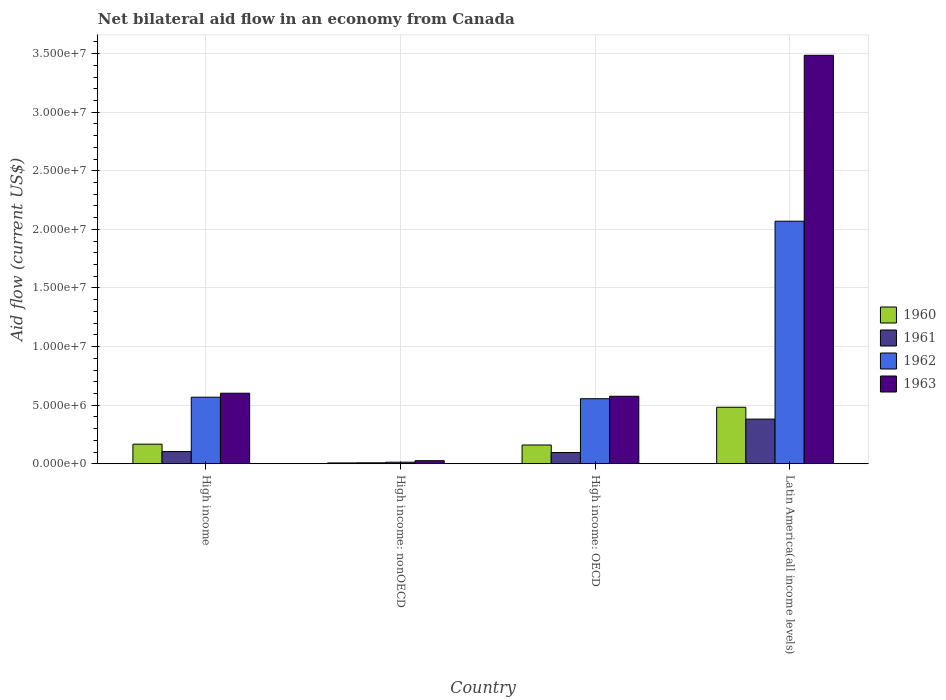Are the number of bars on each tick of the X-axis equal?
Your response must be concise. Yes. How many bars are there on the 4th tick from the left?
Make the answer very short. 4. How many bars are there on the 1st tick from the right?
Keep it short and to the point. 4. In how many cases, is the number of bars for a given country not equal to the number of legend labels?
Provide a short and direct response. 0. Across all countries, what is the maximum net bilateral aid flow in 1963?
Your response must be concise. 3.49e+07. Across all countries, what is the minimum net bilateral aid flow in 1961?
Make the answer very short. 8.00e+04. In which country was the net bilateral aid flow in 1961 maximum?
Provide a short and direct response. Latin America(all income levels). In which country was the net bilateral aid flow in 1961 minimum?
Ensure brevity in your answer.  High income: nonOECD. What is the total net bilateral aid flow in 1960 in the graph?
Keep it short and to the point. 8.16e+06. What is the difference between the net bilateral aid flow in 1963 in High income and that in High income: nonOECD?
Keep it short and to the point. 5.76e+06. What is the difference between the net bilateral aid flow in 1962 in Latin America(all income levels) and the net bilateral aid flow in 1960 in High income: OECD?
Offer a terse response. 1.91e+07. What is the average net bilateral aid flow in 1962 per country?
Your response must be concise. 8.02e+06. What is the difference between the net bilateral aid flow of/in 1960 and net bilateral aid flow of/in 1961 in High income: nonOECD?
Ensure brevity in your answer.  -10000. What is the ratio of the net bilateral aid flow in 1962 in High income to that in High income: nonOECD?
Ensure brevity in your answer.  43.69. Is the net bilateral aid flow in 1962 in High income less than that in High income: nonOECD?
Give a very brief answer. No. Is the difference between the net bilateral aid flow in 1960 in High income and High income: OECD greater than the difference between the net bilateral aid flow in 1961 in High income and High income: OECD?
Offer a very short reply. No. What is the difference between the highest and the second highest net bilateral aid flow in 1961?
Give a very brief answer. 2.85e+06. What is the difference between the highest and the lowest net bilateral aid flow in 1962?
Provide a short and direct response. 2.06e+07. Is the sum of the net bilateral aid flow in 1961 in High income: OECD and Latin America(all income levels) greater than the maximum net bilateral aid flow in 1963 across all countries?
Ensure brevity in your answer.  No. What does the 4th bar from the left in High income: nonOECD represents?
Keep it short and to the point. 1963. What does the 1st bar from the right in High income: OECD represents?
Make the answer very short. 1963. How many bars are there?
Your answer should be compact. 16. Are all the bars in the graph horizontal?
Offer a very short reply. No. How many countries are there in the graph?
Make the answer very short. 4. What is the difference between two consecutive major ticks on the Y-axis?
Give a very brief answer. 5.00e+06. Are the values on the major ticks of Y-axis written in scientific E-notation?
Offer a very short reply. Yes. Does the graph contain grids?
Provide a succinct answer. Yes. Where does the legend appear in the graph?
Give a very brief answer. Center right. How many legend labels are there?
Provide a succinct answer. 4. What is the title of the graph?
Ensure brevity in your answer.  Net bilateral aid flow in an economy from Canada. Does "1990" appear as one of the legend labels in the graph?
Ensure brevity in your answer.  No. What is the Aid flow (current US$) in 1960 in High income?
Make the answer very short. 1.67e+06. What is the Aid flow (current US$) of 1961 in High income?
Ensure brevity in your answer.  1.04e+06. What is the Aid flow (current US$) of 1962 in High income?
Your answer should be compact. 5.68e+06. What is the Aid flow (current US$) in 1963 in High income?
Ensure brevity in your answer.  6.02e+06. What is the Aid flow (current US$) of 1963 in High income: nonOECD?
Offer a very short reply. 2.60e+05. What is the Aid flow (current US$) of 1960 in High income: OECD?
Provide a succinct answer. 1.60e+06. What is the Aid flow (current US$) of 1961 in High income: OECD?
Make the answer very short. 9.60e+05. What is the Aid flow (current US$) in 1962 in High income: OECD?
Your response must be concise. 5.55e+06. What is the Aid flow (current US$) of 1963 in High income: OECD?
Your answer should be compact. 5.76e+06. What is the Aid flow (current US$) of 1960 in Latin America(all income levels)?
Ensure brevity in your answer.  4.82e+06. What is the Aid flow (current US$) of 1961 in Latin America(all income levels)?
Provide a short and direct response. 3.81e+06. What is the Aid flow (current US$) in 1962 in Latin America(all income levels)?
Your answer should be compact. 2.07e+07. What is the Aid flow (current US$) in 1963 in Latin America(all income levels)?
Ensure brevity in your answer.  3.49e+07. Across all countries, what is the maximum Aid flow (current US$) of 1960?
Your answer should be very brief. 4.82e+06. Across all countries, what is the maximum Aid flow (current US$) of 1961?
Make the answer very short. 3.81e+06. Across all countries, what is the maximum Aid flow (current US$) of 1962?
Keep it short and to the point. 2.07e+07. Across all countries, what is the maximum Aid flow (current US$) of 1963?
Your response must be concise. 3.49e+07. Across all countries, what is the minimum Aid flow (current US$) in 1960?
Provide a short and direct response. 7.00e+04. Across all countries, what is the minimum Aid flow (current US$) in 1961?
Your response must be concise. 8.00e+04. Across all countries, what is the minimum Aid flow (current US$) in 1963?
Provide a succinct answer. 2.60e+05. What is the total Aid flow (current US$) of 1960 in the graph?
Provide a short and direct response. 8.16e+06. What is the total Aid flow (current US$) of 1961 in the graph?
Your answer should be very brief. 5.89e+06. What is the total Aid flow (current US$) of 1962 in the graph?
Your answer should be very brief. 3.21e+07. What is the total Aid flow (current US$) in 1963 in the graph?
Your answer should be compact. 4.69e+07. What is the difference between the Aid flow (current US$) of 1960 in High income and that in High income: nonOECD?
Provide a short and direct response. 1.60e+06. What is the difference between the Aid flow (current US$) of 1961 in High income and that in High income: nonOECD?
Offer a very short reply. 9.60e+05. What is the difference between the Aid flow (current US$) in 1962 in High income and that in High income: nonOECD?
Provide a short and direct response. 5.55e+06. What is the difference between the Aid flow (current US$) of 1963 in High income and that in High income: nonOECD?
Your answer should be compact. 5.76e+06. What is the difference between the Aid flow (current US$) of 1963 in High income and that in High income: OECD?
Ensure brevity in your answer.  2.60e+05. What is the difference between the Aid flow (current US$) of 1960 in High income and that in Latin America(all income levels)?
Your response must be concise. -3.15e+06. What is the difference between the Aid flow (current US$) in 1961 in High income and that in Latin America(all income levels)?
Keep it short and to the point. -2.77e+06. What is the difference between the Aid flow (current US$) of 1962 in High income and that in Latin America(all income levels)?
Ensure brevity in your answer.  -1.50e+07. What is the difference between the Aid flow (current US$) of 1963 in High income and that in Latin America(all income levels)?
Your response must be concise. -2.88e+07. What is the difference between the Aid flow (current US$) in 1960 in High income: nonOECD and that in High income: OECD?
Provide a succinct answer. -1.53e+06. What is the difference between the Aid flow (current US$) in 1961 in High income: nonOECD and that in High income: OECD?
Offer a terse response. -8.80e+05. What is the difference between the Aid flow (current US$) of 1962 in High income: nonOECD and that in High income: OECD?
Your response must be concise. -5.42e+06. What is the difference between the Aid flow (current US$) of 1963 in High income: nonOECD and that in High income: OECD?
Offer a terse response. -5.50e+06. What is the difference between the Aid flow (current US$) in 1960 in High income: nonOECD and that in Latin America(all income levels)?
Your response must be concise. -4.75e+06. What is the difference between the Aid flow (current US$) of 1961 in High income: nonOECD and that in Latin America(all income levels)?
Your response must be concise. -3.73e+06. What is the difference between the Aid flow (current US$) in 1962 in High income: nonOECD and that in Latin America(all income levels)?
Ensure brevity in your answer.  -2.06e+07. What is the difference between the Aid flow (current US$) of 1963 in High income: nonOECD and that in Latin America(all income levels)?
Ensure brevity in your answer.  -3.46e+07. What is the difference between the Aid flow (current US$) of 1960 in High income: OECD and that in Latin America(all income levels)?
Your response must be concise. -3.22e+06. What is the difference between the Aid flow (current US$) in 1961 in High income: OECD and that in Latin America(all income levels)?
Provide a succinct answer. -2.85e+06. What is the difference between the Aid flow (current US$) in 1962 in High income: OECD and that in Latin America(all income levels)?
Give a very brief answer. -1.52e+07. What is the difference between the Aid flow (current US$) in 1963 in High income: OECD and that in Latin America(all income levels)?
Keep it short and to the point. -2.91e+07. What is the difference between the Aid flow (current US$) in 1960 in High income and the Aid flow (current US$) in 1961 in High income: nonOECD?
Keep it short and to the point. 1.59e+06. What is the difference between the Aid flow (current US$) in 1960 in High income and the Aid flow (current US$) in 1962 in High income: nonOECD?
Ensure brevity in your answer.  1.54e+06. What is the difference between the Aid flow (current US$) of 1960 in High income and the Aid flow (current US$) of 1963 in High income: nonOECD?
Offer a very short reply. 1.41e+06. What is the difference between the Aid flow (current US$) in 1961 in High income and the Aid flow (current US$) in 1962 in High income: nonOECD?
Keep it short and to the point. 9.10e+05. What is the difference between the Aid flow (current US$) of 1961 in High income and the Aid flow (current US$) of 1963 in High income: nonOECD?
Your answer should be compact. 7.80e+05. What is the difference between the Aid flow (current US$) in 1962 in High income and the Aid flow (current US$) in 1963 in High income: nonOECD?
Give a very brief answer. 5.42e+06. What is the difference between the Aid flow (current US$) of 1960 in High income and the Aid flow (current US$) of 1961 in High income: OECD?
Your response must be concise. 7.10e+05. What is the difference between the Aid flow (current US$) in 1960 in High income and the Aid flow (current US$) in 1962 in High income: OECD?
Offer a terse response. -3.88e+06. What is the difference between the Aid flow (current US$) in 1960 in High income and the Aid flow (current US$) in 1963 in High income: OECD?
Your answer should be compact. -4.09e+06. What is the difference between the Aid flow (current US$) in 1961 in High income and the Aid flow (current US$) in 1962 in High income: OECD?
Your answer should be compact. -4.51e+06. What is the difference between the Aid flow (current US$) in 1961 in High income and the Aid flow (current US$) in 1963 in High income: OECD?
Make the answer very short. -4.72e+06. What is the difference between the Aid flow (current US$) in 1960 in High income and the Aid flow (current US$) in 1961 in Latin America(all income levels)?
Your response must be concise. -2.14e+06. What is the difference between the Aid flow (current US$) of 1960 in High income and the Aid flow (current US$) of 1962 in Latin America(all income levels)?
Your response must be concise. -1.90e+07. What is the difference between the Aid flow (current US$) in 1960 in High income and the Aid flow (current US$) in 1963 in Latin America(all income levels)?
Your answer should be very brief. -3.32e+07. What is the difference between the Aid flow (current US$) in 1961 in High income and the Aid flow (current US$) in 1962 in Latin America(all income levels)?
Provide a short and direct response. -1.97e+07. What is the difference between the Aid flow (current US$) in 1961 in High income and the Aid flow (current US$) in 1963 in Latin America(all income levels)?
Provide a short and direct response. -3.38e+07. What is the difference between the Aid flow (current US$) in 1962 in High income and the Aid flow (current US$) in 1963 in Latin America(all income levels)?
Offer a terse response. -2.92e+07. What is the difference between the Aid flow (current US$) in 1960 in High income: nonOECD and the Aid flow (current US$) in 1961 in High income: OECD?
Offer a very short reply. -8.90e+05. What is the difference between the Aid flow (current US$) of 1960 in High income: nonOECD and the Aid flow (current US$) of 1962 in High income: OECD?
Keep it short and to the point. -5.48e+06. What is the difference between the Aid flow (current US$) of 1960 in High income: nonOECD and the Aid flow (current US$) of 1963 in High income: OECD?
Keep it short and to the point. -5.69e+06. What is the difference between the Aid flow (current US$) in 1961 in High income: nonOECD and the Aid flow (current US$) in 1962 in High income: OECD?
Offer a very short reply. -5.47e+06. What is the difference between the Aid flow (current US$) in 1961 in High income: nonOECD and the Aid flow (current US$) in 1963 in High income: OECD?
Your answer should be very brief. -5.68e+06. What is the difference between the Aid flow (current US$) of 1962 in High income: nonOECD and the Aid flow (current US$) of 1963 in High income: OECD?
Make the answer very short. -5.63e+06. What is the difference between the Aid flow (current US$) of 1960 in High income: nonOECD and the Aid flow (current US$) of 1961 in Latin America(all income levels)?
Provide a succinct answer. -3.74e+06. What is the difference between the Aid flow (current US$) in 1960 in High income: nonOECD and the Aid flow (current US$) in 1962 in Latin America(all income levels)?
Offer a very short reply. -2.06e+07. What is the difference between the Aid flow (current US$) in 1960 in High income: nonOECD and the Aid flow (current US$) in 1963 in Latin America(all income levels)?
Offer a terse response. -3.48e+07. What is the difference between the Aid flow (current US$) in 1961 in High income: nonOECD and the Aid flow (current US$) in 1962 in Latin America(all income levels)?
Keep it short and to the point. -2.06e+07. What is the difference between the Aid flow (current US$) in 1961 in High income: nonOECD and the Aid flow (current US$) in 1963 in Latin America(all income levels)?
Provide a succinct answer. -3.48e+07. What is the difference between the Aid flow (current US$) of 1962 in High income: nonOECD and the Aid flow (current US$) of 1963 in Latin America(all income levels)?
Offer a very short reply. -3.47e+07. What is the difference between the Aid flow (current US$) of 1960 in High income: OECD and the Aid flow (current US$) of 1961 in Latin America(all income levels)?
Offer a very short reply. -2.21e+06. What is the difference between the Aid flow (current US$) in 1960 in High income: OECD and the Aid flow (current US$) in 1962 in Latin America(all income levels)?
Keep it short and to the point. -1.91e+07. What is the difference between the Aid flow (current US$) in 1960 in High income: OECD and the Aid flow (current US$) in 1963 in Latin America(all income levels)?
Offer a terse response. -3.33e+07. What is the difference between the Aid flow (current US$) in 1961 in High income: OECD and the Aid flow (current US$) in 1962 in Latin America(all income levels)?
Provide a short and direct response. -1.97e+07. What is the difference between the Aid flow (current US$) in 1961 in High income: OECD and the Aid flow (current US$) in 1963 in Latin America(all income levels)?
Ensure brevity in your answer.  -3.39e+07. What is the difference between the Aid flow (current US$) in 1962 in High income: OECD and the Aid flow (current US$) in 1963 in Latin America(all income levels)?
Offer a very short reply. -2.93e+07. What is the average Aid flow (current US$) in 1960 per country?
Offer a terse response. 2.04e+06. What is the average Aid flow (current US$) of 1961 per country?
Provide a succinct answer. 1.47e+06. What is the average Aid flow (current US$) in 1962 per country?
Provide a succinct answer. 8.02e+06. What is the average Aid flow (current US$) in 1963 per country?
Provide a short and direct response. 1.17e+07. What is the difference between the Aid flow (current US$) of 1960 and Aid flow (current US$) of 1961 in High income?
Offer a very short reply. 6.30e+05. What is the difference between the Aid flow (current US$) in 1960 and Aid flow (current US$) in 1962 in High income?
Offer a very short reply. -4.01e+06. What is the difference between the Aid flow (current US$) in 1960 and Aid flow (current US$) in 1963 in High income?
Ensure brevity in your answer.  -4.35e+06. What is the difference between the Aid flow (current US$) of 1961 and Aid flow (current US$) of 1962 in High income?
Offer a very short reply. -4.64e+06. What is the difference between the Aid flow (current US$) in 1961 and Aid flow (current US$) in 1963 in High income?
Your answer should be very brief. -4.98e+06. What is the difference between the Aid flow (current US$) in 1962 and Aid flow (current US$) in 1963 in High income?
Keep it short and to the point. -3.40e+05. What is the difference between the Aid flow (current US$) in 1960 and Aid flow (current US$) in 1961 in High income: nonOECD?
Offer a very short reply. -10000. What is the difference between the Aid flow (current US$) in 1960 and Aid flow (current US$) in 1962 in High income: nonOECD?
Your answer should be compact. -6.00e+04. What is the difference between the Aid flow (current US$) in 1960 and Aid flow (current US$) in 1963 in High income: nonOECD?
Offer a very short reply. -1.90e+05. What is the difference between the Aid flow (current US$) of 1961 and Aid flow (current US$) of 1962 in High income: nonOECD?
Your response must be concise. -5.00e+04. What is the difference between the Aid flow (current US$) of 1960 and Aid flow (current US$) of 1961 in High income: OECD?
Your answer should be very brief. 6.40e+05. What is the difference between the Aid flow (current US$) of 1960 and Aid flow (current US$) of 1962 in High income: OECD?
Provide a succinct answer. -3.95e+06. What is the difference between the Aid flow (current US$) of 1960 and Aid flow (current US$) of 1963 in High income: OECD?
Keep it short and to the point. -4.16e+06. What is the difference between the Aid flow (current US$) in 1961 and Aid flow (current US$) in 1962 in High income: OECD?
Offer a terse response. -4.59e+06. What is the difference between the Aid flow (current US$) of 1961 and Aid flow (current US$) of 1963 in High income: OECD?
Offer a terse response. -4.80e+06. What is the difference between the Aid flow (current US$) in 1960 and Aid flow (current US$) in 1961 in Latin America(all income levels)?
Offer a terse response. 1.01e+06. What is the difference between the Aid flow (current US$) of 1960 and Aid flow (current US$) of 1962 in Latin America(all income levels)?
Your response must be concise. -1.59e+07. What is the difference between the Aid flow (current US$) in 1960 and Aid flow (current US$) in 1963 in Latin America(all income levels)?
Keep it short and to the point. -3.00e+07. What is the difference between the Aid flow (current US$) of 1961 and Aid flow (current US$) of 1962 in Latin America(all income levels)?
Provide a short and direct response. -1.69e+07. What is the difference between the Aid flow (current US$) of 1961 and Aid flow (current US$) of 1963 in Latin America(all income levels)?
Offer a very short reply. -3.10e+07. What is the difference between the Aid flow (current US$) in 1962 and Aid flow (current US$) in 1963 in Latin America(all income levels)?
Offer a terse response. -1.42e+07. What is the ratio of the Aid flow (current US$) of 1960 in High income to that in High income: nonOECD?
Your answer should be compact. 23.86. What is the ratio of the Aid flow (current US$) of 1962 in High income to that in High income: nonOECD?
Give a very brief answer. 43.69. What is the ratio of the Aid flow (current US$) of 1963 in High income to that in High income: nonOECD?
Your response must be concise. 23.15. What is the ratio of the Aid flow (current US$) of 1960 in High income to that in High income: OECD?
Make the answer very short. 1.04. What is the ratio of the Aid flow (current US$) of 1962 in High income to that in High income: OECD?
Ensure brevity in your answer.  1.02. What is the ratio of the Aid flow (current US$) of 1963 in High income to that in High income: OECD?
Your answer should be compact. 1.05. What is the ratio of the Aid flow (current US$) of 1960 in High income to that in Latin America(all income levels)?
Offer a terse response. 0.35. What is the ratio of the Aid flow (current US$) in 1961 in High income to that in Latin America(all income levels)?
Provide a succinct answer. 0.27. What is the ratio of the Aid flow (current US$) of 1962 in High income to that in Latin America(all income levels)?
Give a very brief answer. 0.27. What is the ratio of the Aid flow (current US$) in 1963 in High income to that in Latin America(all income levels)?
Give a very brief answer. 0.17. What is the ratio of the Aid flow (current US$) in 1960 in High income: nonOECD to that in High income: OECD?
Offer a very short reply. 0.04. What is the ratio of the Aid flow (current US$) in 1961 in High income: nonOECD to that in High income: OECD?
Keep it short and to the point. 0.08. What is the ratio of the Aid flow (current US$) in 1962 in High income: nonOECD to that in High income: OECD?
Keep it short and to the point. 0.02. What is the ratio of the Aid flow (current US$) in 1963 in High income: nonOECD to that in High income: OECD?
Provide a short and direct response. 0.05. What is the ratio of the Aid flow (current US$) in 1960 in High income: nonOECD to that in Latin America(all income levels)?
Your answer should be very brief. 0.01. What is the ratio of the Aid flow (current US$) in 1961 in High income: nonOECD to that in Latin America(all income levels)?
Your answer should be very brief. 0.02. What is the ratio of the Aid flow (current US$) of 1962 in High income: nonOECD to that in Latin America(all income levels)?
Your answer should be very brief. 0.01. What is the ratio of the Aid flow (current US$) in 1963 in High income: nonOECD to that in Latin America(all income levels)?
Provide a short and direct response. 0.01. What is the ratio of the Aid flow (current US$) in 1960 in High income: OECD to that in Latin America(all income levels)?
Your answer should be very brief. 0.33. What is the ratio of the Aid flow (current US$) in 1961 in High income: OECD to that in Latin America(all income levels)?
Ensure brevity in your answer.  0.25. What is the ratio of the Aid flow (current US$) in 1962 in High income: OECD to that in Latin America(all income levels)?
Your response must be concise. 0.27. What is the ratio of the Aid flow (current US$) of 1963 in High income: OECD to that in Latin America(all income levels)?
Your answer should be compact. 0.17. What is the difference between the highest and the second highest Aid flow (current US$) in 1960?
Ensure brevity in your answer.  3.15e+06. What is the difference between the highest and the second highest Aid flow (current US$) of 1961?
Keep it short and to the point. 2.77e+06. What is the difference between the highest and the second highest Aid flow (current US$) of 1962?
Keep it short and to the point. 1.50e+07. What is the difference between the highest and the second highest Aid flow (current US$) of 1963?
Give a very brief answer. 2.88e+07. What is the difference between the highest and the lowest Aid flow (current US$) in 1960?
Your answer should be very brief. 4.75e+06. What is the difference between the highest and the lowest Aid flow (current US$) of 1961?
Your response must be concise. 3.73e+06. What is the difference between the highest and the lowest Aid flow (current US$) in 1962?
Keep it short and to the point. 2.06e+07. What is the difference between the highest and the lowest Aid flow (current US$) in 1963?
Give a very brief answer. 3.46e+07. 